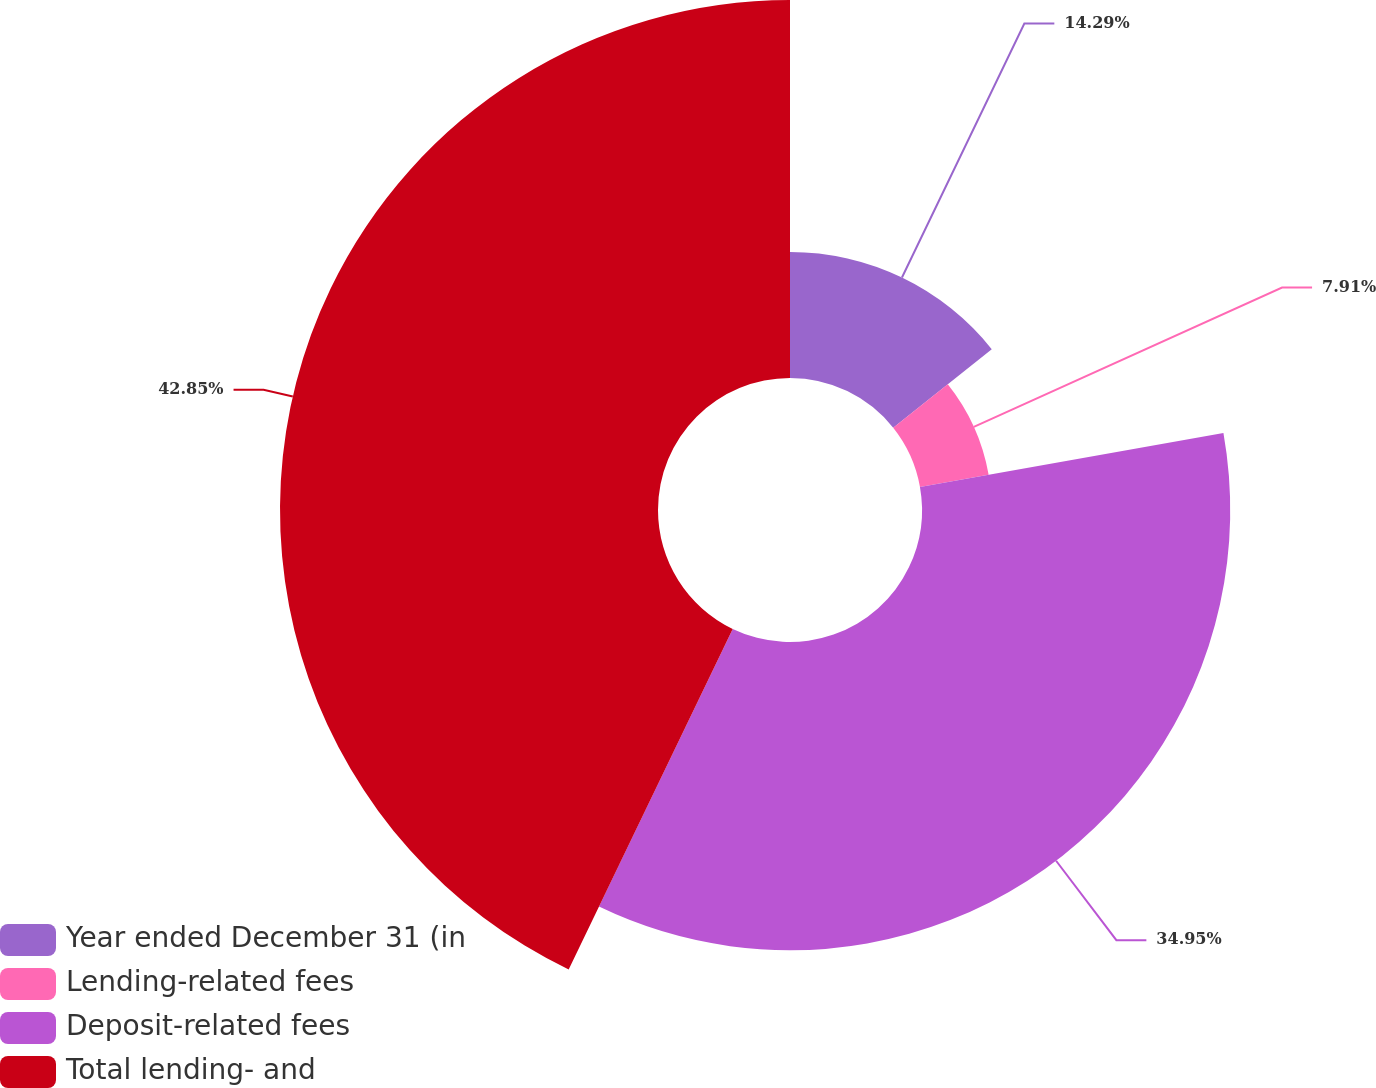Convert chart. <chart><loc_0><loc_0><loc_500><loc_500><pie_chart><fcel>Year ended December 31 (in<fcel>Lending-related fees<fcel>Deposit-related fees<fcel>Total lending- and<nl><fcel>14.29%<fcel>7.91%<fcel>34.95%<fcel>42.86%<nl></chart> 